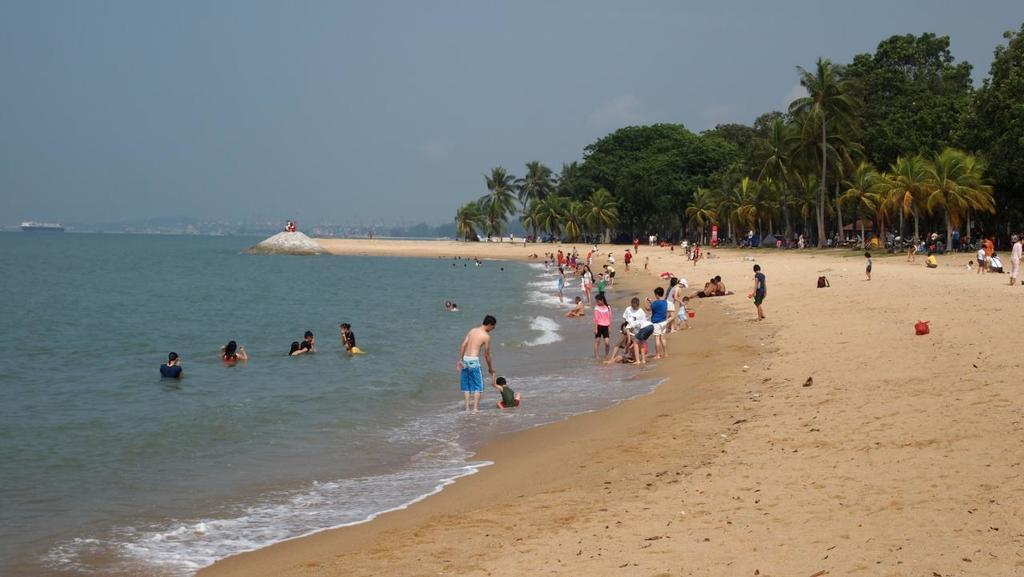Describe this image in one or two sentences. In this image there are people on the land having bags and few objects. Left side there are people in the water. There is a ship sailing on the surface of the water. Background there are hills. Right side there are trees. Top of the image there is sky. 